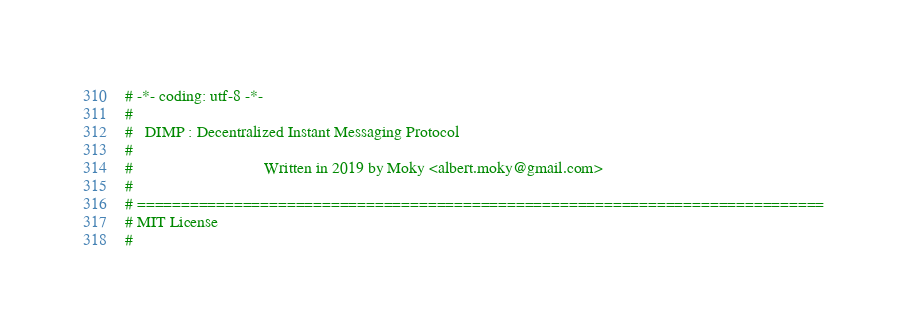<code> <loc_0><loc_0><loc_500><loc_500><_Python_># -*- coding: utf-8 -*-
#
#   DIMP : Decentralized Instant Messaging Protocol
#
#                                Written in 2019 by Moky <albert.moky@gmail.com>
#
# ==============================================================================
# MIT License
#</code> 